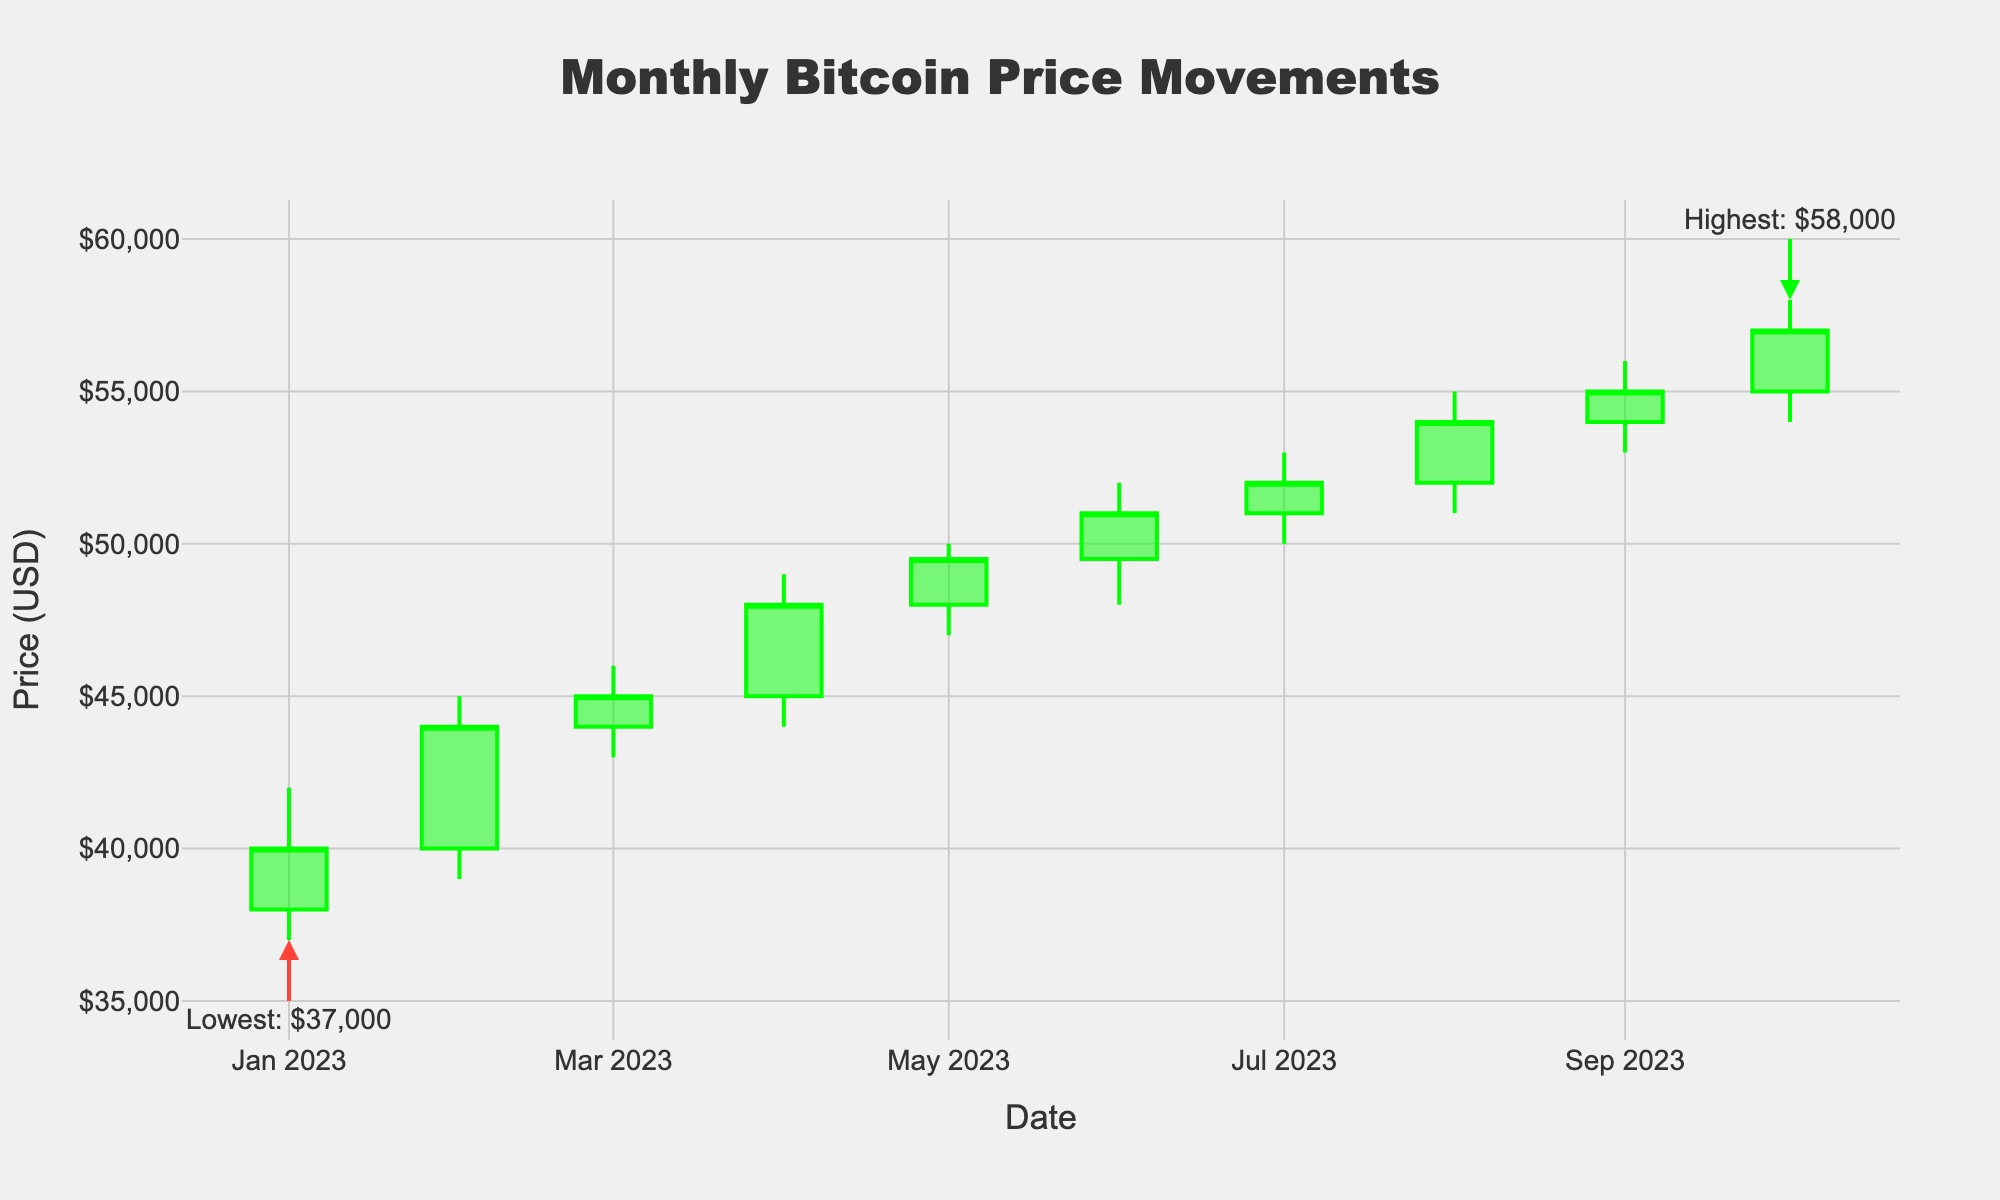What's the title of the plot? The title is typically located at the top center of the plot. It helps viewers understand what the plot is about. In this case, the title is "Monthly Bitcoin Price Movements".
Answer: Monthly Bitcoin Price Movements What do the green and red lines represent? In a candlestick plot, colors indicate whether the closing price was higher or lower than the opening price. Green lines (candles) show that the close was higher than the open, indicating a price increase. Red lines (candles) show that the close was lower than the open, indicating a price decrease.
Answer: Price increase and price decrease Which month had the highest Bitcoin price? To find the month with the highest price, look at the "high" values across the months. The highest annotated point will indicate the highest value. According to the annotation, August 2023 had the highest Bitcoin price of $55,000.
Answer: August 2023 What is the lowest Bitcoin price in the plotted months? The lowest price can be identified by locating the annotated point for the lowest value. The annotation shows that in January 2023, the Bitcoin price reached the lowest value of $37,000.
Answer: $37,000 How many months had a closing price above $50,000? To determine the number of months with closing prices above $50,000, count the candlesticks where the closing price, indicated at the top of the body for green candles or bottom for red candles, exceeds $50,000. There are five months: June, July, August, September, and October 2023.
Answer: 5 What was the closing price in June 2023? Find June 2023 on the x-axis, and look at the corresponding candlestick. The closing price is noted at the top of the green candle for June, which is $51,000.
Answer: $51,000 Which month had the smallest range between the high and low prices? The range between the high and low prices is the smallest when the difference is minimal. Checking the plotted data, March 2023 had a high of $46,000 and a low of $43,000, which is the smallest range of $3,000.
Answer: March 2023 Compare the opening price in January 2023 and February 2023. Which is higher? Look at the opening prices of January and February. January's opening price is $38,000, while February's is $40,000. February's opening price is higher.
Answer: February 2023 Which month experienced the highest increase from open to close price? To find the highest increase, calculate the difference between open and close prices for each month and identify the maximum. February 2023 had the highest increase with an opening of $40,000 and a closing of $44,000, an increase of $4,000.
Answer: February 2023 How does the price movement in October 2023 compare to September 2023? Compare the closing prices for September and October. September closed at $55,000, and October closed at $57,000, indicating an increase in the price movement from September to October.
Answer: October's price increased compared to September 